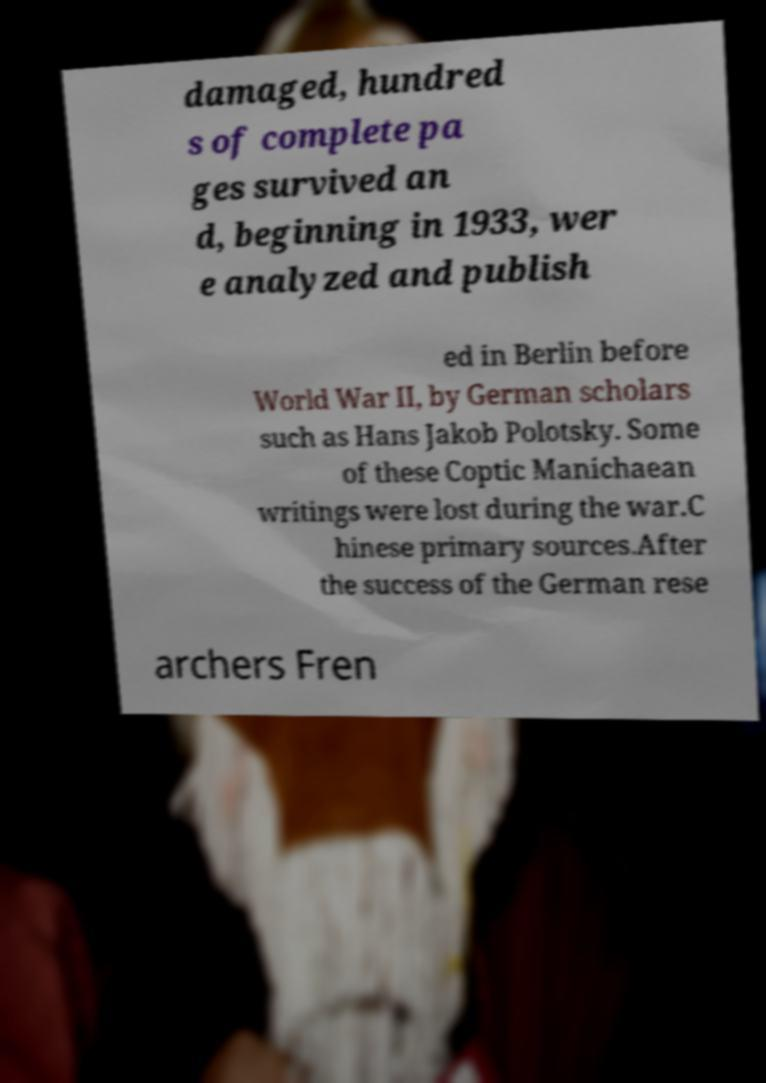Could you extract and type out the text from this image? damaged, hundred s of complete pa ges survived an d, beginning in 1933, wer e analyzed and publish ed in Berlin before World War II, by German scholars such as Hans Jakob Polotsky. Some of these Coptic Manichaean writings were lost during the war.C hinese primary sources.After the success of the German rese archers Fren 